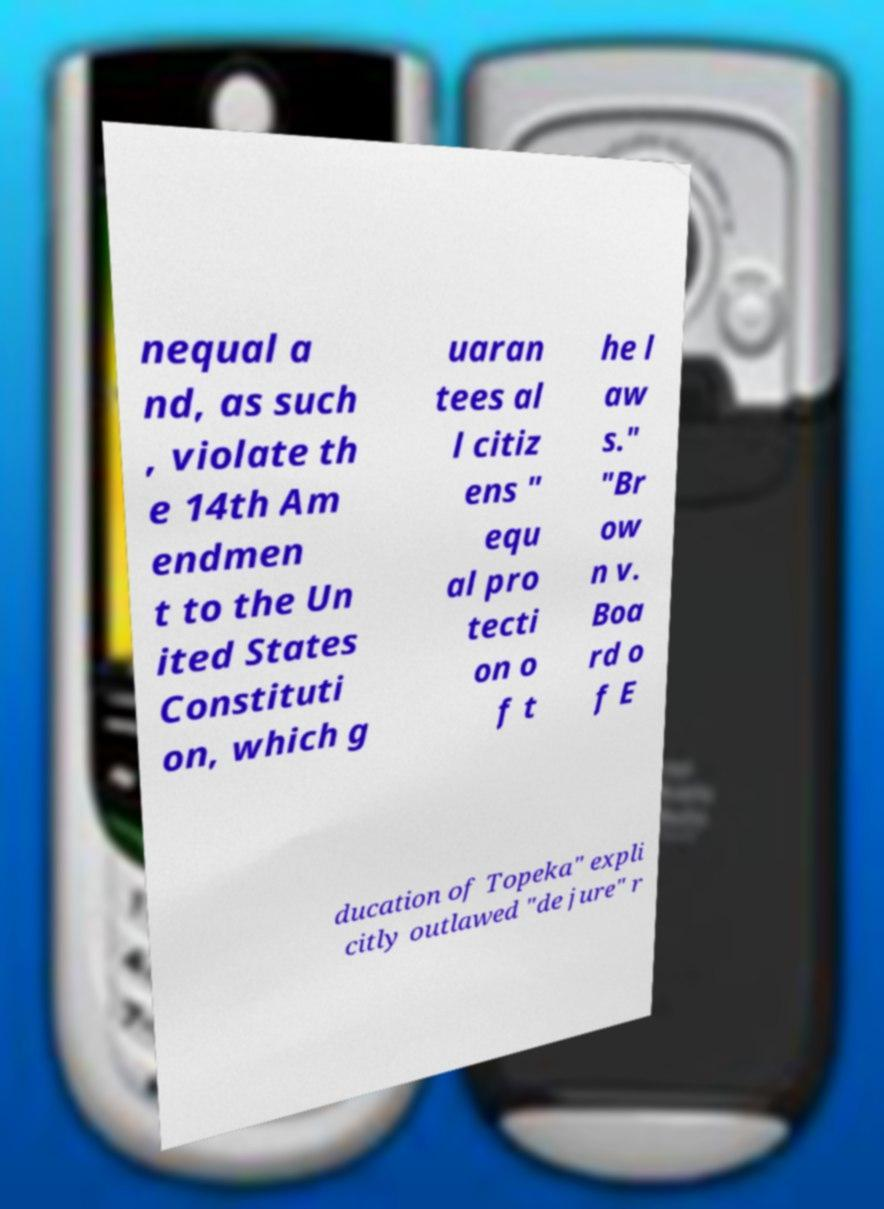I need the written content from this picture converted into text. Can you do that? nequal a nd, as such , violate th e 14th Am endmen t to the Un ited States Constituti on, which g uaran tees al l citiz ens " equ al pro tecti on o f t he l aw s." "Br ow n v. Boa rd o f E ducation of Topeka" expli citly outlawed "de jure" r 